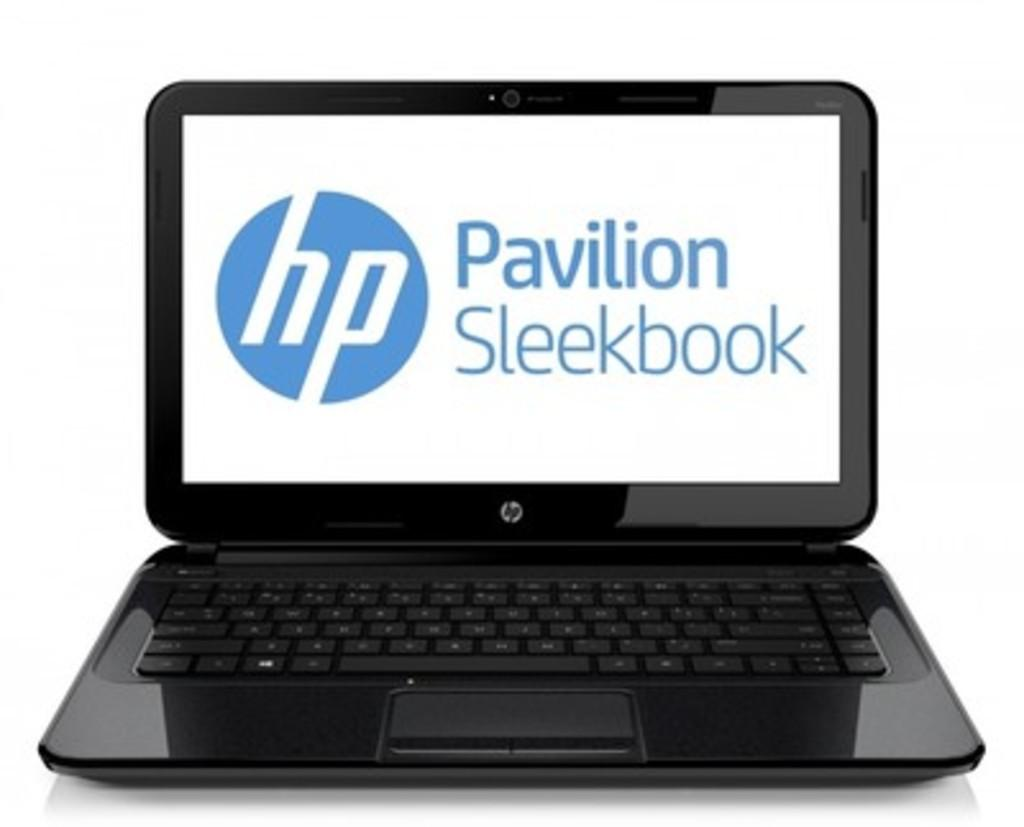<image>
Offer a succinct explanation of the picture presented. a laptop with the words pavilion sleekbook on the screen. 